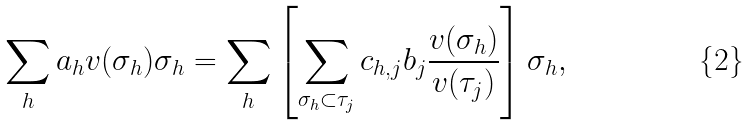Convert formula to latex. <formula><loc_0><loc_0><loc_500><loc_500>\sum _ { h } a _ { h } v ( \sigma _ { h } ) \sigma _ { h } = \sum _ { h } \left [ \sum _ { \sigma _ { h } \subset \tau _ { j } } c _ { h , j } b _ { j } \frac { v ( \sigma _ { h } ) } { v ( \tau _ { j } ) } \right ] \sigma _ { h } ,</formula> 